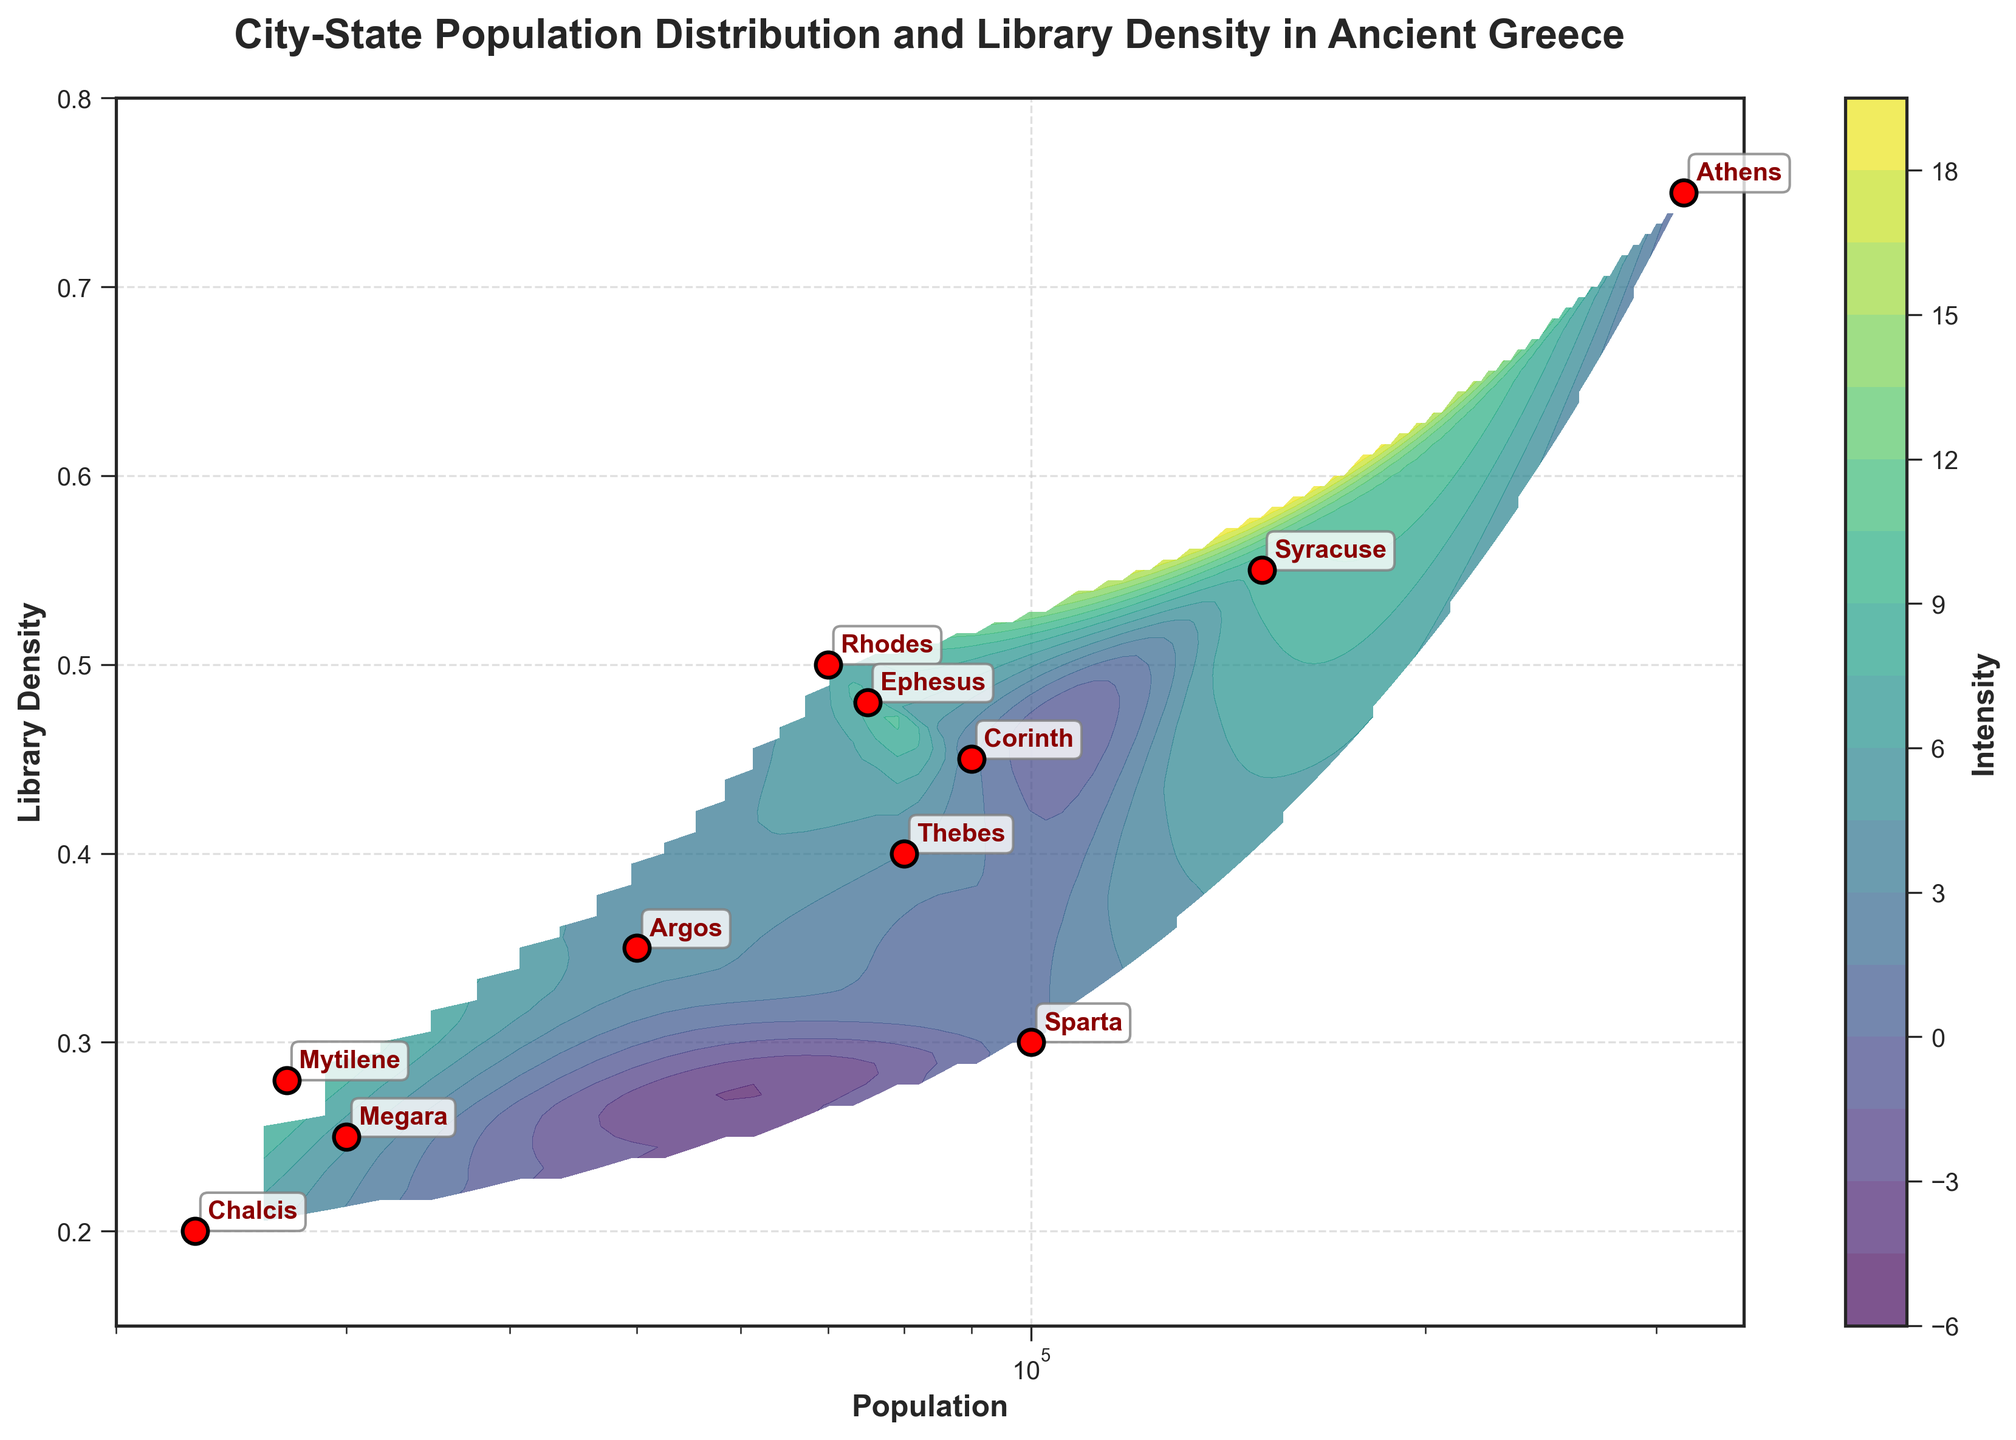What is the title of the plot? The title is given at the top of the plot. It reads “City-State Population Distribution and Library Density in Ancient Greece”.
Answer: City-State Population Distribution and Library Density in Ancient Greece How many city-states are represented as points in the plot? The plot features red scatter points, and if you count them, there are 11 points, each representing a city-state.
Answer: 11 Which city-state has the highest population? The highest population will be the point furthest to the right along the x-axis (Population). With 315,000, the point labeled "Athens" is the furthest right.
Answer: Athens What city-state has the lowest library density? The lowest library density is the point closest to the bottom of the y-axis. This point (0.20 density) is labeled "Chalcis".
Answer: Chalcis What is the population of Rhodes? The population of each city-state is indicated on the x-axis where the point is annotated. The point labeled "Rhodes" corresponds to a population size of 70,000.
Answer: 70,000 What is the average library density of Athens and Sparta? Athens has a library density of 0.75 and Sparta has 0.30. The average is calculated as (0.75 + 0.30) / 2.
Answer: 0.525 Which city-state has a higher library density, Syracuse or Ephesus? Compare the library density values on the y-axis. Syracuse has 0.55 and Ephesus has 0.48.
Answer: Syracuse Which city-state combination marks the overall highest values for library density and population simultaneously? Look for the city-state markers placed at the furthest right (highest population) and top (highest library density) coordinates. Athens (315,000 population, 0.75 library density) tops both metrics.
Answer: Athens Are there any city-states with a library density approximately 0.35? Observing the points near the y-axis values of 0.35. Argos (0.35) meets this criterion.
Answer: Argos Which city-states fall within a population range of 50,000 to 100,000 and library density range of 0.30 to 0.50? Look for data points within the x-axis range 50,000-100,000 and y-axis 0.30-0.50. Sparta, Corinth, Thebes, and Ephesus match these criteria.
Answer: Sparta, Corinth, Thebes, Ephesus 